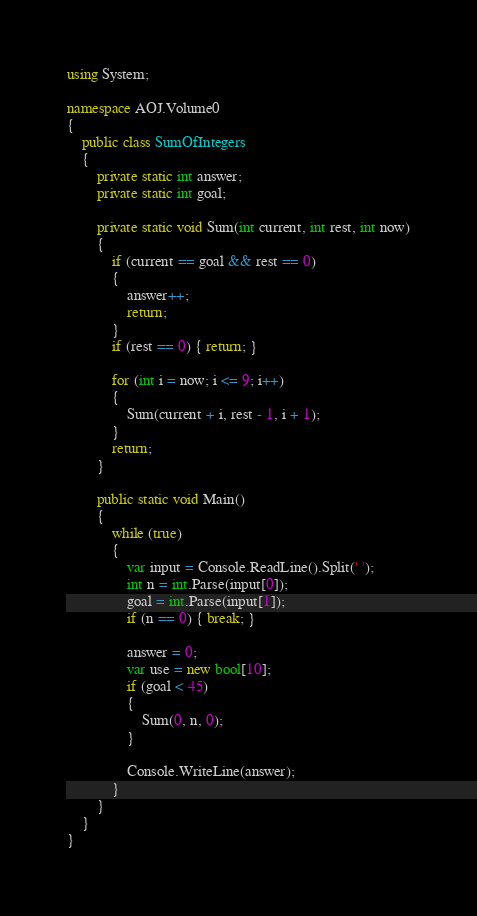<code> <loc_0><loc_0><loc_500><loc_500><_C#_>using System;

namespace AOJ.Volume0
{
    public class SumOfIntegers
    {
        private static int answer;
        private static int goal;

        private static void Sum(int current, int rest, int now)
        {
            if (current == goal && rest == 0)
            {
                answer++;
                return;
            }
            if (rest == 0) { return; }

            for (int i = now; i <= 9; i++)
            {
                Sum(current + i, rest - 1, i + 1);
            }
            return;
        }

        public static void Main()
        {
            while (true)
            {
                var input = Console.ReadLine().Split(' ');
                int n = int.Parse(input[0]);
                goal = int.Parse(input[1]);
                if (n == 0) { break; }

                answer = 0;
                var use = new bool[10];
                if (goal < 45)
                {
                    Sum(0, n, 0);
                }

                Console.WriteLine(answer);
            }
        }
    }
}</code> 